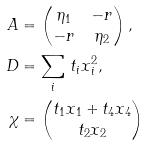<formula> <loc_0><loc_0><loc_500><loc_500>A & = \left ( \begin{matrix} \eta _ { 1 } & - r \\ - r & \eta _ { 2 } \end{matrix} \right ) , \\ D & = \sum _ { i } \, t _ { i } x _ { i } ^ { 2 } , \\ \chi & = \left ( \begin{matrix} t _ { 1 } x _ { 1 } + t _ { 4 } x _ { 4 } \\ t _ { 2 } x _ { 2 } \end{matrix} \right )</formula> 